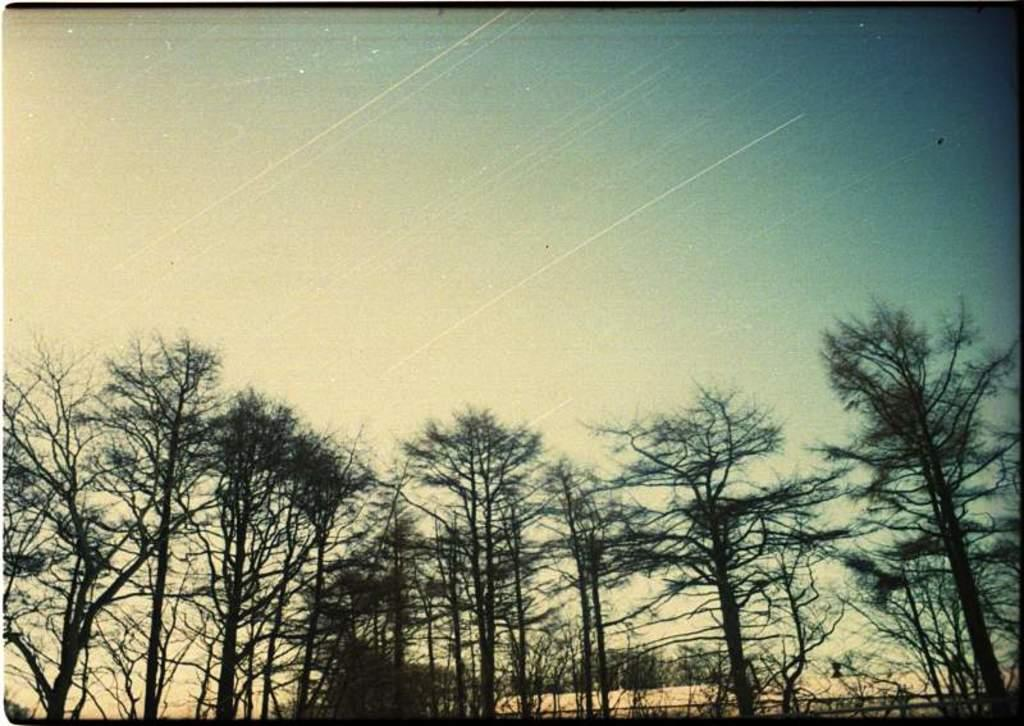What type of vegetation can be seen in the image? There are trees in the image. What part of the natural environment is visible in the image? The sky is visible in the image. Where is the crown located in the image? There is no crown present in the image. What type of cattle can be seen grazing in the image? There is no cattle present in the image. 